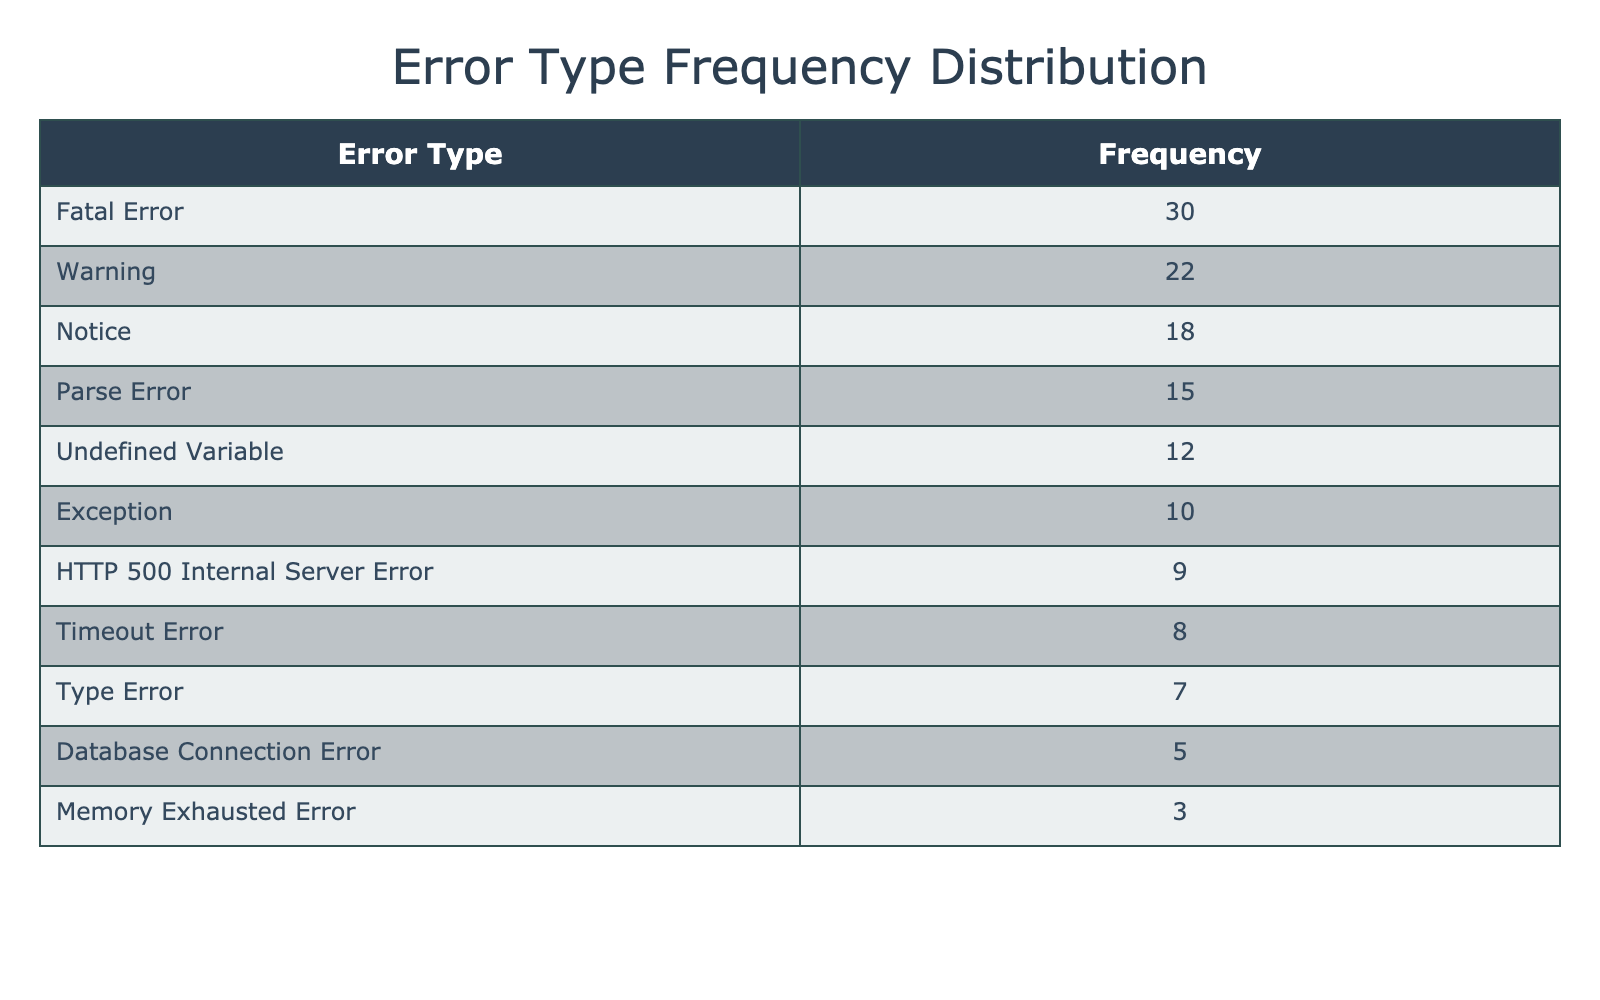What is the most frequently encountered error type? The most frequently encountered error type can be found by looking at the "Frequency" column and identifying the maximum value. In this case, the "Fatal Error" has a frequency of 30, which is the highest among all error types listed.
Answer: Fatal Error How many errors were classified as warnings? To find the number of errors classified as warnings, simply refer to the "Frequency" column for "Warning." The table shows that the frequency for "Warning" is 22.
Answer: 22 What is the total frequency of all error types listed in the table? To find the total frequency, add up all the frequencies provided in the table: 15 (Parse Error) + 30 (Fatal Error) + 22 (Warning) + 18 (Notice) + 10 (Exception) + 5 (Database Connection Error) + 8 (Timeout Error) + 3 (Memory Exhausted Error) + 9 (HTTP 500 Internal Server Error) + 12 (Undefined Variable) + 7 (Type Error) =  1 + 13 + 7 = 121.
Answer: 121 Is the "Database Connection Error" more frequent than "Memory Exhausted Error"? To determine if "Database Connection Error" is more frequent, compare their frequencies in the table. "Database Connection Error" has a frequency of 5, while "Memory Exhausted Error" has a frequency of 3. Since 5 is greater than 3, the answer is true.
Answer: Yes What is the average frequency of all the error types? To calculate the average frequency, first sum up all the frequencies as previously mentioned: the total is 121. Then, divide this sum by the number of error types, which is 10. Thus, the average is 121 / 10 = 12.1.
Answer: 12.1 